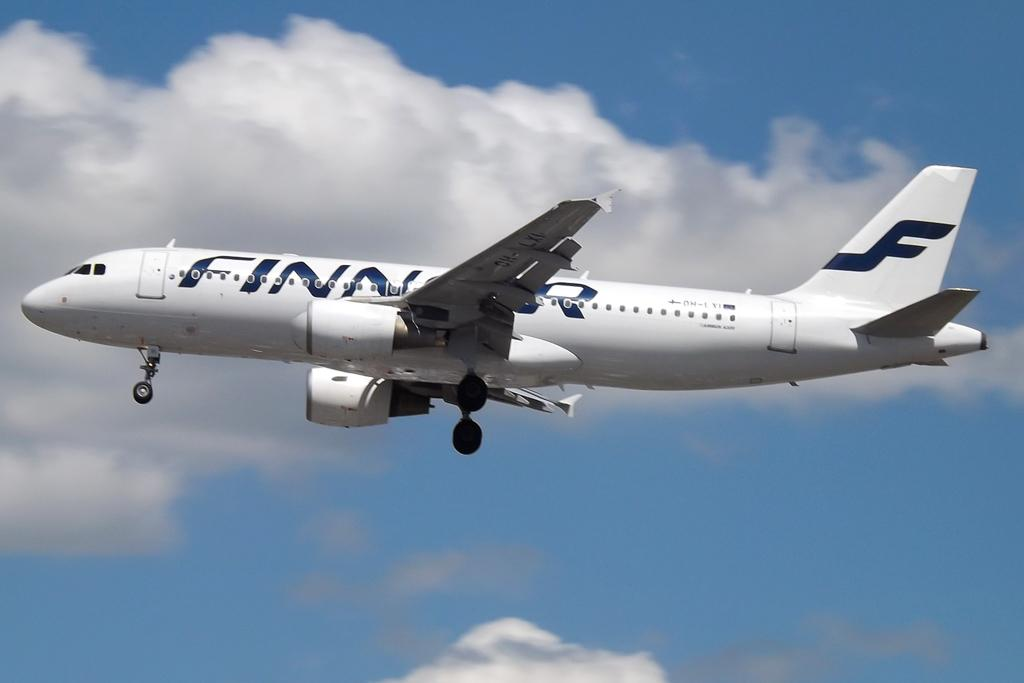<image>
Offer a succinct explanation of the picture presented. A Finnair aircraft soars through a bright blue, lightly cloudy sky. 